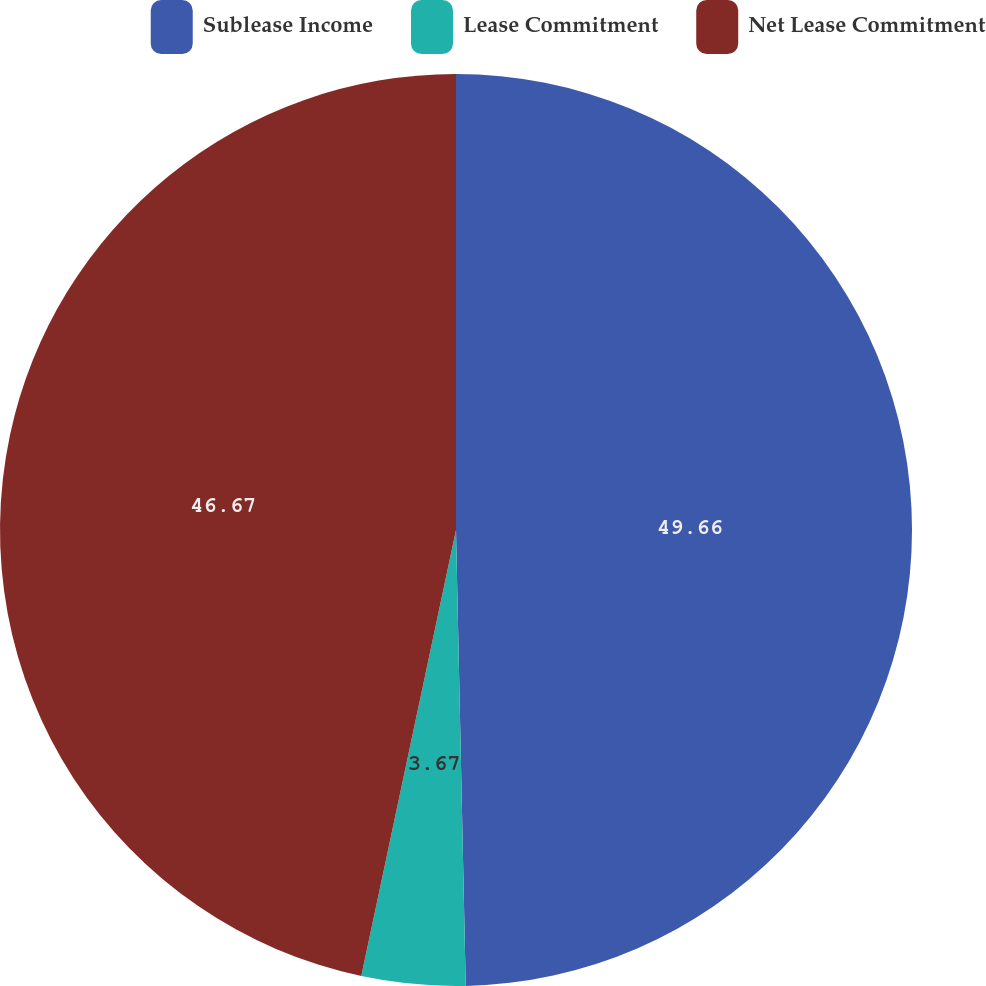Convert chart. <chart><loc_0><loc_0><loc_500><loc_500><pie_chart><fcel>Sublease Income<fcel>Lease Commitment<fcel>Net Lease Commitment<nl><fcel>49.66%<fcel>3.67%<fcel>46.67%<nl></chart> 